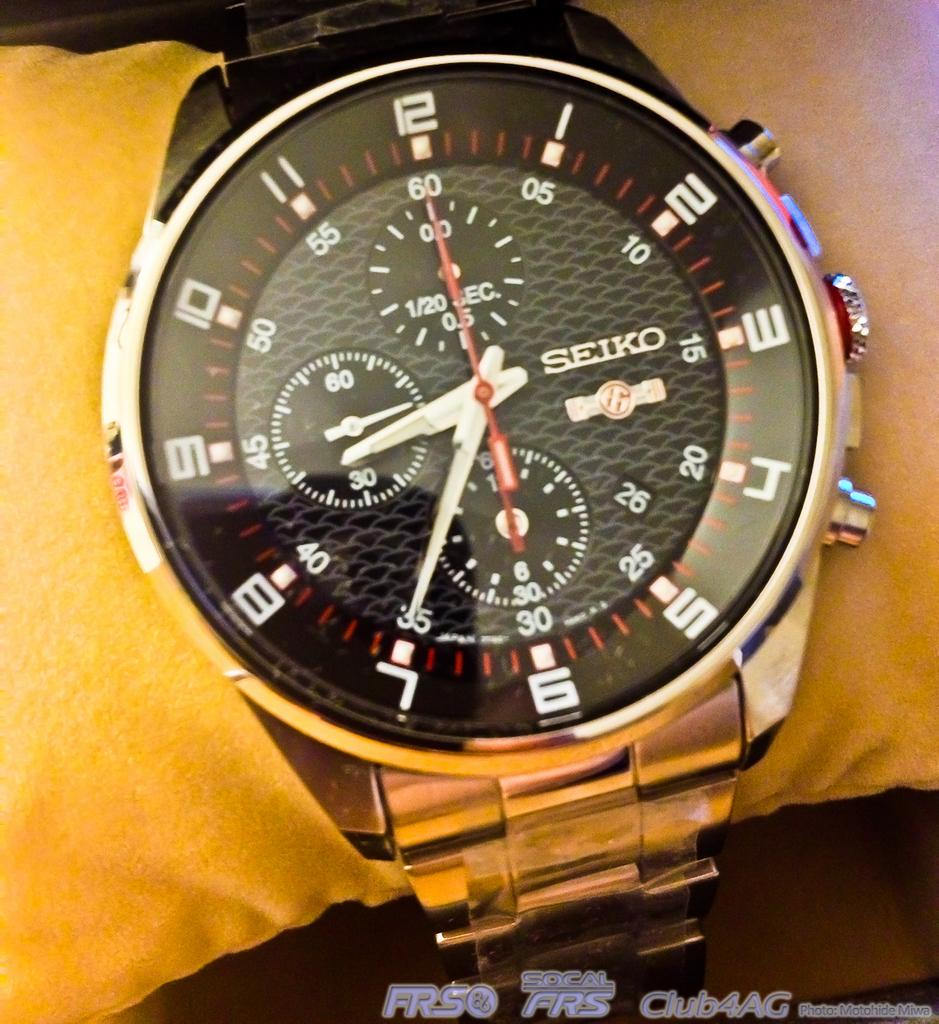Provide a one-sentence caption for the provided image. A Seiko watch is worn on the arm of someone wearing a yellow shirt. 